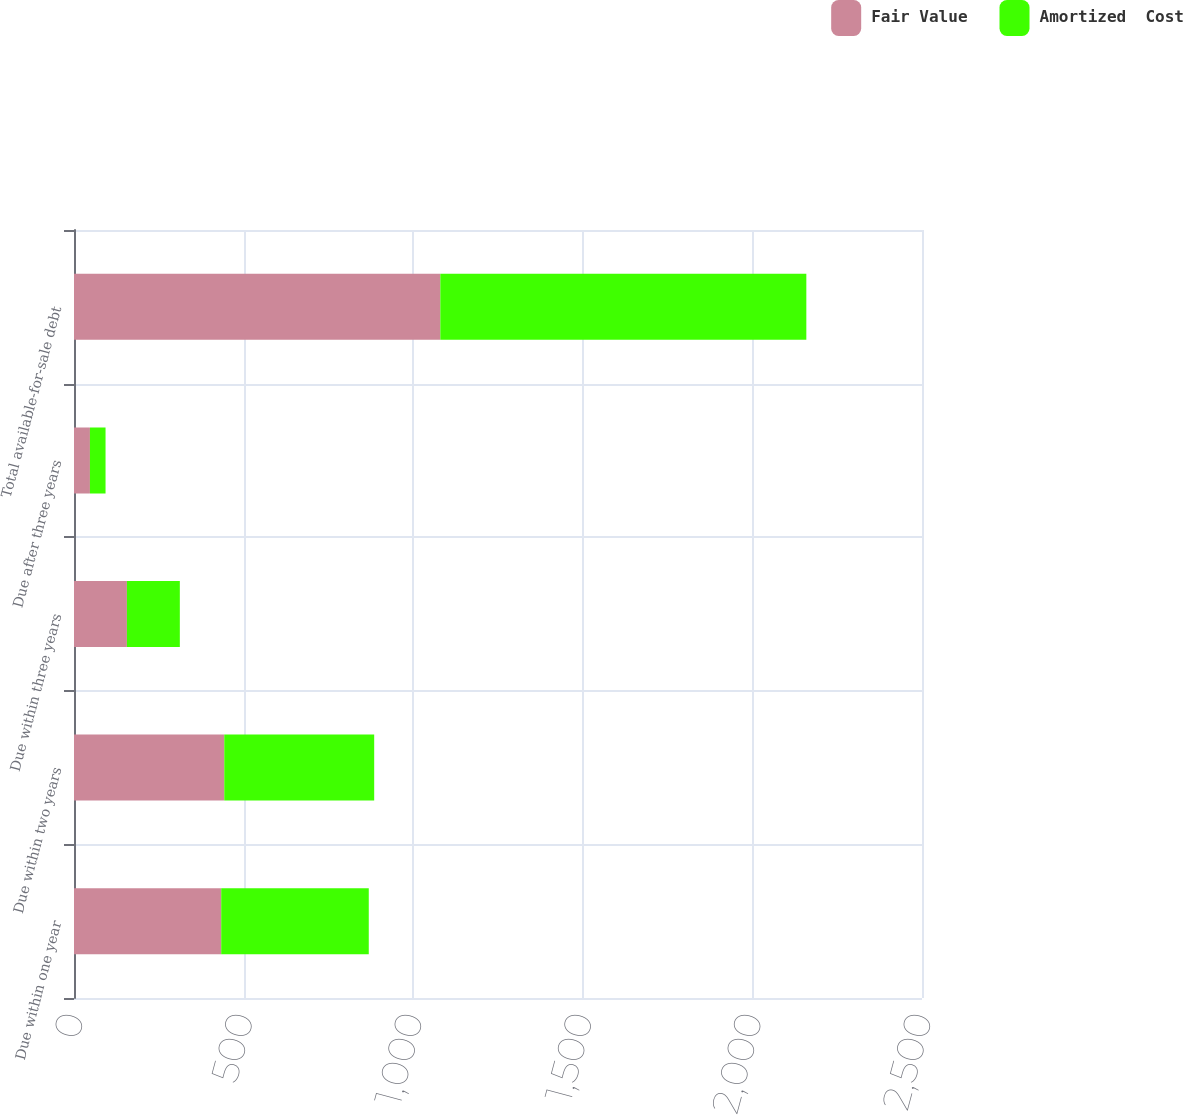Convert chart. <chart><loc_0><loc_0><loc_500><loc_500><stacked_bar_chart><ecel><fcel>Due within one year<fcel>Due within two years<fcel>Due within three years<fcel>Due after three years<fcel>Total available-for-sale debt<nl><fcel>Fair Value<fcel>434<fcel>443<fcel>156<fcel>47<fcel>1080<nl><fcel>Amortized  Cost<fcel>435<fcel>442<fcel>156<fcel>46<fcel>1079<nl></chart> 